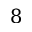<formula> <loc_0><loc_0><loc_500><loc_500>8</formula> 